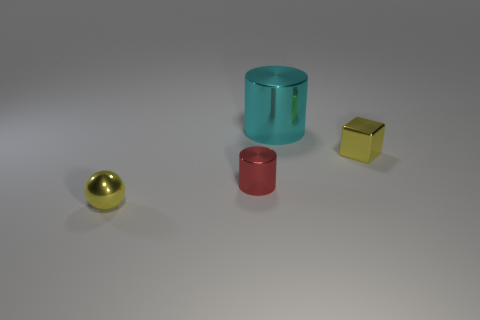Are there any other things that have the same size as the cyan metallic cylinder?
Provide a succinct answer. No. Are there more metal cylinders that are to the left of the big cylinder than metal cylinders that are in front of the tiny yellow metallic sphere?
Provide a succinct answer. Yes. What number of other things are there of the same size as the yellow block?
Keep it short and to the point. 2. What size is the ball that is the same color as the small metal cube?
Provide a succinct answer. Small. The small thing left of the cylinder on the left side of the big cyan cylinder is made of what material?
Make the answer very short. Metal. Are there any yellow cubes in front of the red shiny thing?
Provide a short and direct response. No. Is the number of yellow objects behind the small shiny cylinder greater than the number of yellow shiny balls?
Make the answer very short. No. Are there any tiny metal spheres that have the same color as the block?
Provide a short and direct response. Yes. There is a shiny ball that is the same size as the yellow metallic cube; what is its color?
Offer a terse response. Yellow. Are there any cyan metallic cylinders that are right of the cylinder that is behind the small cylinder?
Your response must be concise. No. 